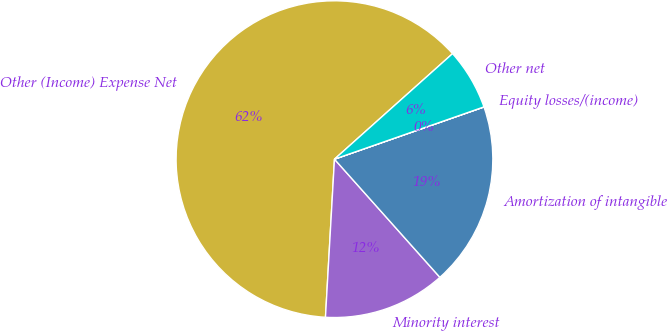Convert chart to OTSL. <chart><loc_0><loc_0><loc_500><loc_500><pie_chart><fcel>Other (Income) Expense Net<fcel>Minority interest<fcel>Amortization of intangible<fcel>Equity losses/(income)<fcel>Other net<nl><fcel>62.49%<fcel>12.5%<fcel>18.75%<fcel>0.01%<fcel>6.25%<nl></chart> 